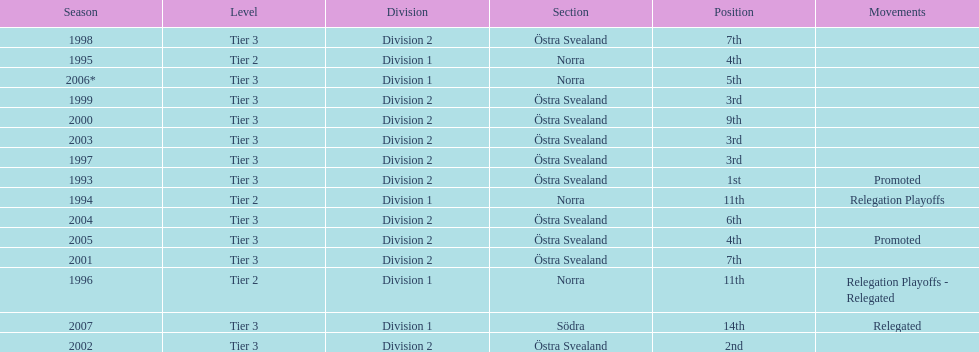What is the only year with the 1st position? 1993. 